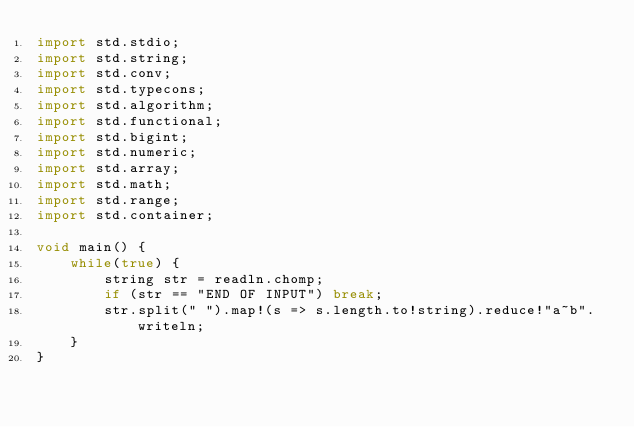Convert code to text. <code><loc_0><loc_0><loc_500><loc_500><_D_>import std.stdio;
import std.string;
import std.conv;
import std.typecons;
import std.algorithm;
import std.functional;
import std.bigint;
import std.numeric;
import std.array;
import std.math;
import std.range;
import std.container;

void main() {
    while(true) {
        string str = readln.chomp;
        if (str == "END OF INPUT") break;
        str.split(" ").map!(s => s.length.to!string).reduce!"a~b".writeln;
    }
}</code> 